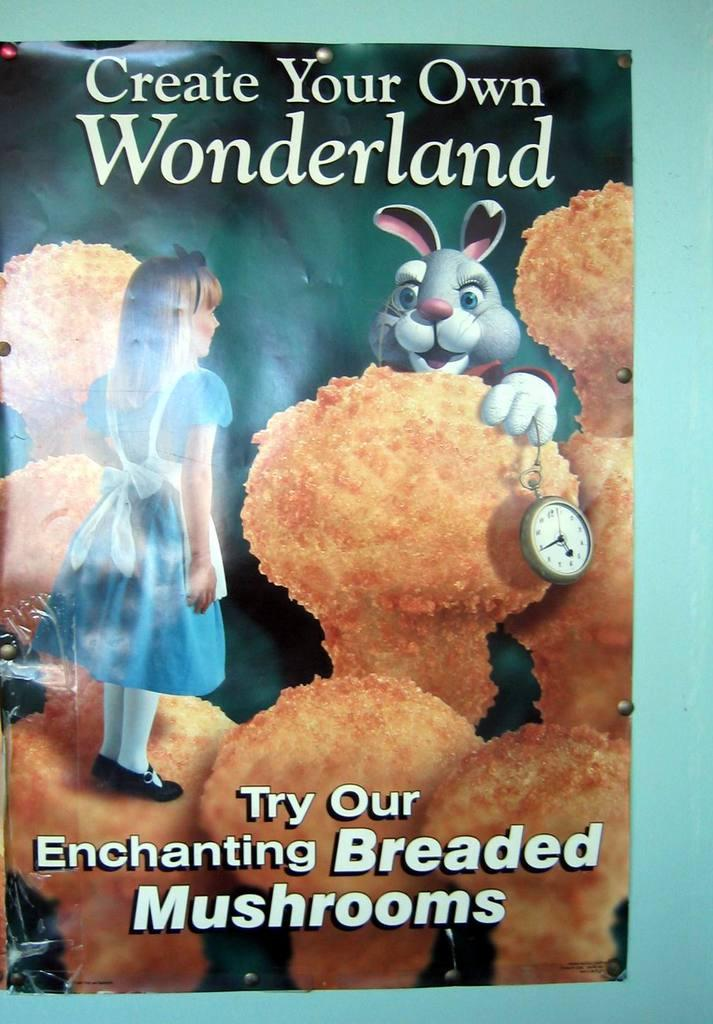<image>
Offer a succinct explanation of the picture presented. A book with a girl and a rabbit on the front that says Create Your Own Wonderland. 